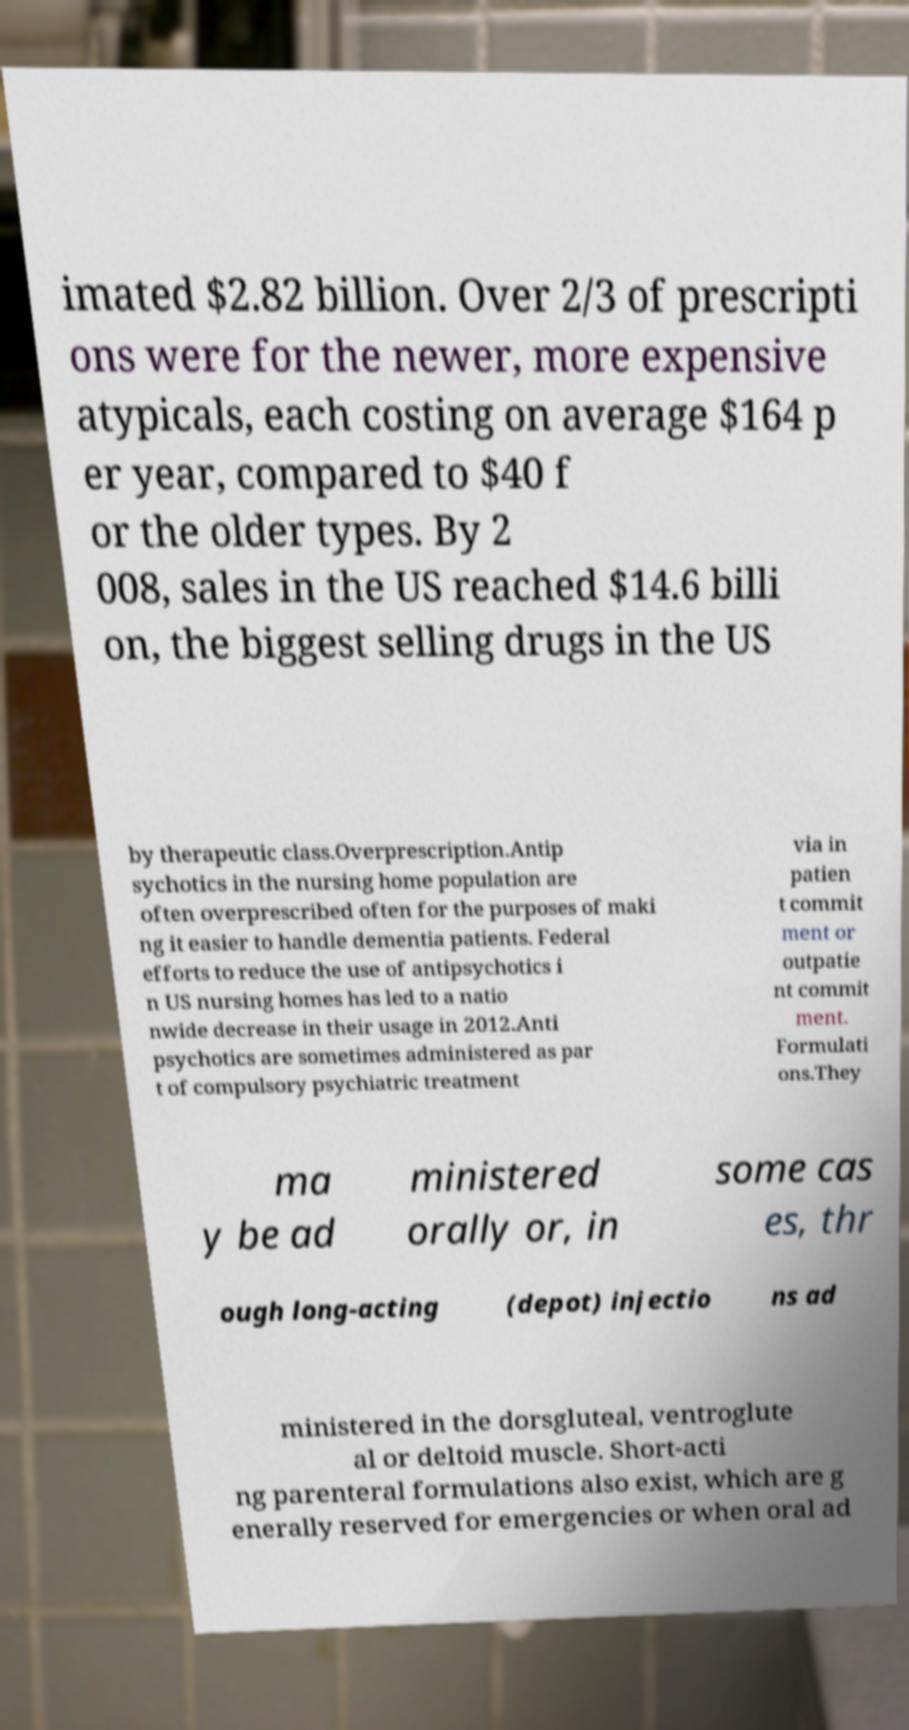Could you extract and type out the text from this image? imated $2.82 billion. Over 2/3 of prescripti ons were for the newer, more expensive atypicals, each costing on average $164 p er year, compared to $40 f or the older types. By 2 008, sales in the US reached $14.6 billi on, the biggest selling drugs in the US by therapeutic class.Overprescription.Antip sychotics in the nursing home population are often overprescribed often for the purposes of maki ng it easier to handle dementia patients. Federal efforts to reduce the use of antipsychotics i n US nursing homes has led to a natio nwide decrease in their usage in 2012.Anti psychotics are sometimes administered as par t of compulsory psychiatric treatment via in patien t commit ment or outpatie nt commit ment. Formulati ons.They ma y be ad ministered orally or, in some cas es, thr ough long-acting (depot) injectio ns ad ministered in the dorsgluteal, ventroglute al or deltoid muscle. Short-acti ng parenteral formulations also exist, which are g enerally reserved for emergencies or when oral ad 